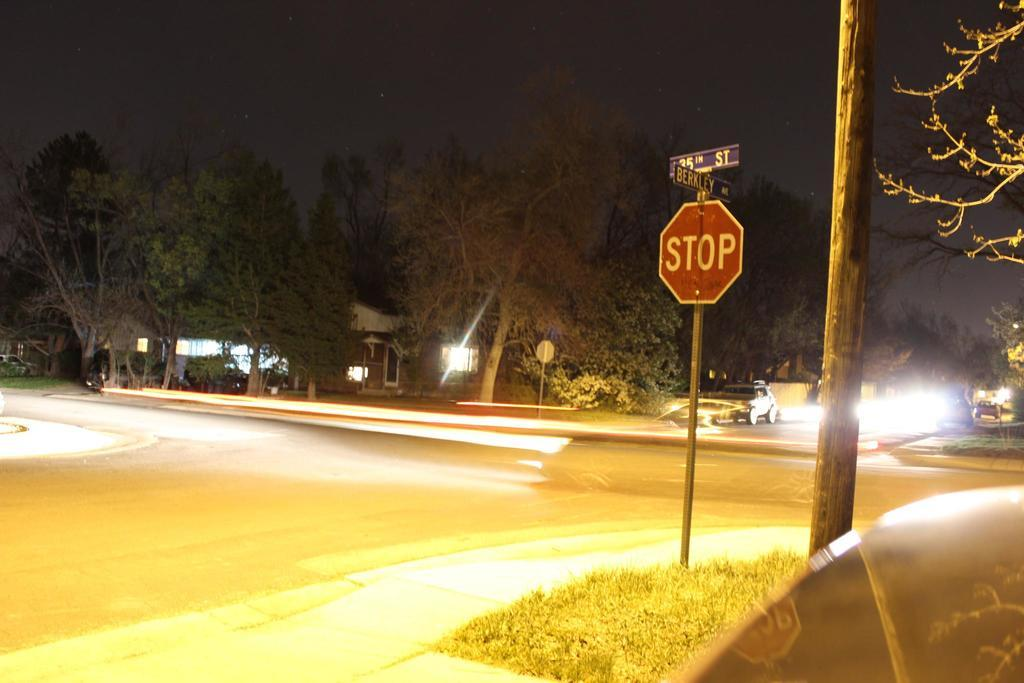<image>
Offer a succinct explanation of the picture presented. a stop sign that is outside and had a pole next to it 